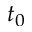Convert formula to latex. <formula><loc_0><loc_0><loc_500><loc_500>t _ { 0 }</formula> 